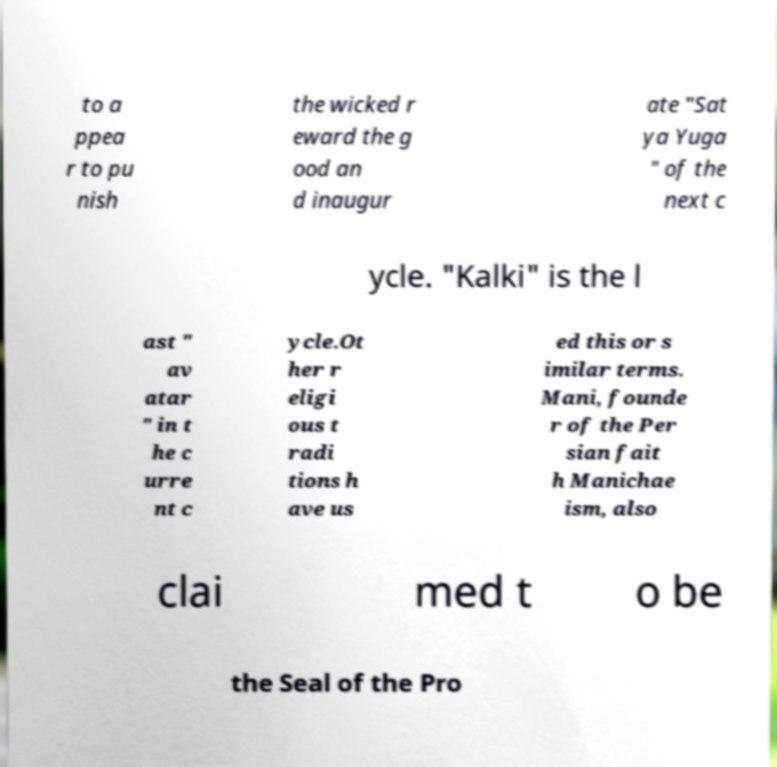I need the written content from this picture converted into text. Can you do that? to a ppea r to pu nish the wicked r eward the g ood an d inaugur ate "Sat ya Yuga " of the next c ycle. "Kalki" is the l ast " av atar " in t he c urre nt c ycle.Ot her r eligi ous t radi tions h ave us ed this or s imilar terms. Mani, founde r of the Per sian fait h Manichae ism, also clai med t o be the Seal of the Pro 